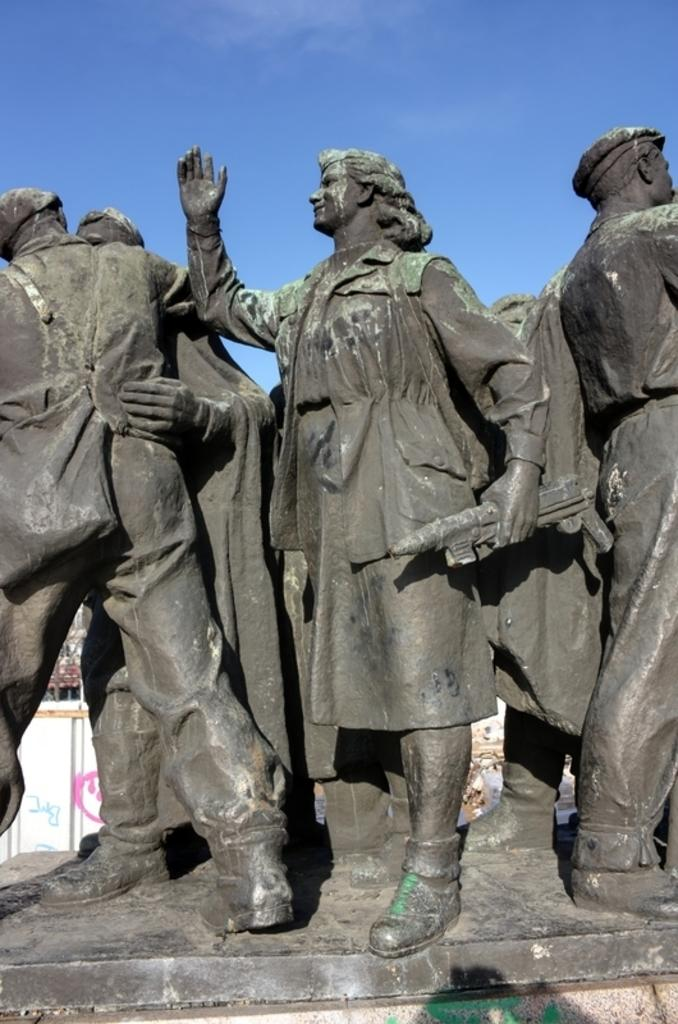What can be seen in the foreground of the image? There are statues in the foreground of the image. What is visible in the background of the image? The sky is visible in the background of the image. What is the color of the sky in the image? The color of the sky is blue. What type of skirt is the statue wearing in the image? The statues in the image are not wearing skirts, as they are inanimate objects and do not have clothing. What smell can be detected in the image? There is no information about smells in the image, as it only provides visual information. 